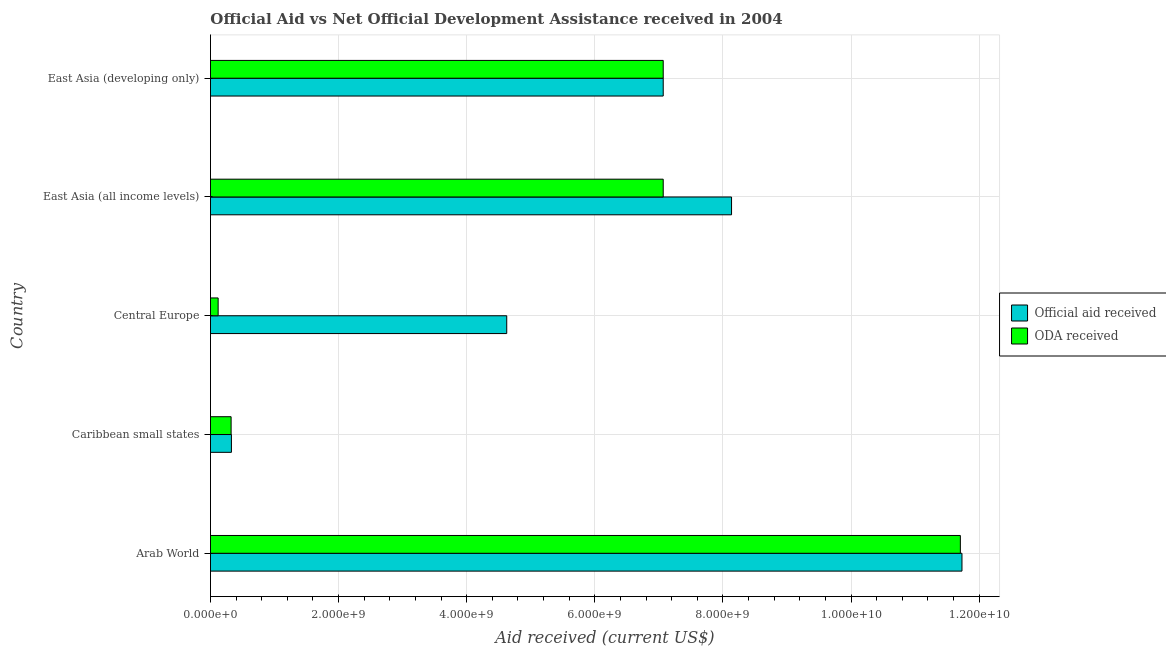How many different coloured bars are there?
Offer a very short reply. 2. Are the number of bars on each tick of the Y-axis equal?
Provide a short and direct response. Yes. How many bars are there on the 1st tick from the top?
Offer a very short reply. 2. What is the label of the 2nd group of bars from the top?
Your answer should be compact. East Asia (all income levels). In how many cases, is the number of bars for a given country not equal to the number of legend labels?
Provide a short and direct response. 0. What is the oda received in East Asia (all income levels)?
Make the answer very short. 7.07e+09. Across all countries, what is the maximum official aid received?
Provide a short and direct response. 1.17e+1. Across all countries, what is the minimum oda received?
Provide a succinct answer. 1.20e+08. In which country was the official aid received maximum?
Offer a very short reply. Arab World. In which country was the oda received minimum?
Offer a terse response. Central Europe. What is the total official aid received in the graph?
Your response must be concise. 3.19e+1. What is the difference between the official aid received in Caribbean small states and that in East Asia (developing only)?
Your answer should be compact. -6.74e+09. What is the difference between the official aid received in East Asia (all income levels) and the oda received in Arab World?
Provide a short and direct response. -3.57e+09. What is the average oda received per country?
Your answer should be very brief. 5.26e+09. What is the difference between the official aid received and oda received in Central Europe?
Give a very brief answer. 4.51e+09. In how many countries, is the official aid received greater than 10800000000 US$?
Give a very brief answer. 1. What is the ratio of the official aid received in Arab World to that in East Asia (all income levels)?
Give a very brief answer. 1.44. Is the official aid received in Arab World less than that in Central Europe?
Give a very brief answer. No. What is the difference between the highest and the second highest oda received?
Keep it short and to the point. 4.64e+09. What is the difference between the highest and the lowest oda received?
Make the answer very short. 1.16e+1. What does the 1st bar from the top in Arab World represents?
Offer a terse response. ODA received. What does the 2nd bar from the bottom in Central Europe represents?
Provide a short and direct response. ODA received. How many bars are there?
Keep it short and to the point. 10. What is the difference between two consecutive major ticks on the X-axis?
Your answer should be compact. 2.00e+09. Does the graph contain any zero values?
Provide a short and direct response. No. How are the legend labels stacked?
Your answer should be compact. Vertical. What is the title of the graph?
Offer a very short reply. Official Aid vs Net Official Development Assistance received in 2004 . Does "Enforce a contract" appear as one of the legend labels in the graph?
Your answer should be very brief. No. What is the label or title of the X-axis?
Provide a short and direct response. Aid received (current US$). What is the label or title of the Y-axis?
Offer a very short reply. Country. What is the Aid received (current US$) in Official aid received in Arab World?
Provide a succinct answer. 1.17e+1. What is the Aid received (current US$) of ODA received in Arab World?
Your answer should be compact. 1.17e+1. What is the Aid received (current US$) of Official aid received in Caribbean small states?
Offer a terse response. 3.27e+08. What is the Aid received (current US$) in ODA received in Caribbean small states?
Make the answer very short. 3.22e+08. What is the Aid received (current US$) in Official aid received in Central Europe?
Give a very brief answer. 4.63e+09. What is the Aid received (current US$) of ODA received in Central Europe?
Provide a short and direct response. 1.20e+08. What is the Aid received (current US$) of Official aid received in East Asia (all income levels)?
Give a very brief answer. 8.13e+09. What is the Aid received (current US$) in ODA received in East Asia (all income levels)?
Keep it short and to the point. 7.07e+09. What is the Aid received (current US$) in Official aid received in East Asia (developing only)?
Your response must be concise. 7.07e+09. What is the Aid received (current US$) in ODA received in East Asia (developing only)?
Provide a succinct answer. 7.07e+09. Across all countries, what is the maximum Aid received (current US$) of Official aid received?
Make the answer very short. 1.17e+1. Across all countries, what is the maximum Aid received (current US$) of ODA received?
Keep it short and to the point. 1.17e+1. Across all countries, what is the minimum Aid received (current US$) of Official aid received?
Your answer should be compact. 3.27e+08. Across all countries, what is the minimum Aid received (current US$) in ODA received?
Offer a terse response. 1.20e+08. What is the total Aid received (current US$) in Official aid received in the graph?
Ensure brevity in your answer.  3.19e+1. What is the total Aid received (current US$) in ODA received in the graph?
Your response must be concise. 2.63e+1. What is the difference between the Aid received (current US$) of Official aid received in Arab World and that in Caribbean small states?
Offer a very short reply. 1.14e+1. What is the difference between the Aid received (current US$) of ODA received in Arab World and that in Caribbean small states?
Make the answer very short. 1.14e+1. What is the difference between the Aid received (current US$) in Official aid received in Arab World and that in Central Europe?
Your response must be concise. 7.11e+09. What is the difference between the Aid received (current US$) in ODA received in Arab World and that in Central Europe?
Your answer should be very brief. 1.16e+1. What is the difference between the Aid received (current US$) in Official aid received in Arab World and that in East Asia (all income levels)?
Offer a terse response. 3.60e+09. What is the difference between the Aid received (current US$) in ODA received in Arab World and that in East Asia (all income levels)?
Give a very brief answer. 4.64e+09. What is the difference between the Aid received (current US$) in Official aid received in Arab World and that in East Asia (developing only)?
Your answer should be compact. 4.66e+09. What is the difference between the Aid received (current US$) of ODA received in Arab World and that in East Asia (developing only)?
Give a very brief answer. 4.64e+09. What is the difference between the Aid received (current US$) in Official aid received in Caribbean small states and that in Central Europe?
Ensure brevity in your answer.  -4.30e+09. What is the difference between the Aid received (current US$) of ODA received in Caribbean small states and that in Central Europe?
Ensure brevity in your answer.  2.03e+08. What is the difference between the Aid received (current US$) of Official aid received in Caribbean small states and that in East Asia (all income levels)?
Offer a very short reply. -7.81e+09. What is the difference between the Aid received (current US$) in ODA received in Caribbean small states and that in East Asia (all income levels)?
Offer a very short reply. -6.75e+09. What is the difference between the Aid received (current US$) of Official aid received in Caribbean small states and that in East Asia (developing only)?
Offer a very short reply. -6.74e+09. What is the difference between the Aid received (current US$) of ODA received in Caribbean small states and that in East Asia (developing only)?
Offer a very short reply. -6.75e+09. What is the difference between the Aid received (current US$) in Official aid received in Central Europe and that in East Asia (all income levels)?
Your answer should be compact. -3.51e+09. What is the difference between the Aid received (current US$) in ODA received in Central Europe and that in East Asia (all income levels)?
Offer a very short reply. -6.95e+09. What is the difference between the Aid received (current US$) in Official aid received in Central Europe and that in East Asia (developing only)?
Offer a very short reply. -2.44e+09. What is the difference between the Aid received (current US$) of ODA received in Central Europe and that in East Asia (developing only)?
Your response must be concise. -6.95e+09. What is the difference between the Aid received (current US$) of Official aid received in East Asia (all income levels) and that in East Asia (developing only)?
Your answer should be very brief. 1.07e+09. What is the difference between the Aid received (current US$) in ODA received in East Asia (all income levels) and that in East Asia (developing only)?
Your response must be concise. 0. What is the difference between the Aid received (current US$) of Official aid received in Arab World and the Aid received (current US$) of ODA received in Caribbean small states?
Provide a succinct answer. 1.14e+1. What is the difference between the Aid received (current US$) of Official aid received in Arab World and the Aid received (current US$) of ODA received in Central Europe?
Your response must be concise. 1.16e+1. What is the difference between the Aid received (current US$) in Official aid received in Arab World and the Aid received (current US$) in ODA received in East Asia (all income levels)?
Your answer should be compact. 4.66e+09. What is the difference between the Aid received (current US$) in Official aid received in Arab World and the Aid received (current US$) in ODA received in East Asia (developing only)?
Offer a very short reply. 4.66e+09. What is the difference between the Aid received (current US$) of Official aid received in Caribbean small states and the Aid received (current US$) of ODA received in Central Europe?
Your response must be concise. 2.07e+08. What is the difference between the Aid received (current US$) in Official aid received in Caribbean small states and the Aid received (current US$) in ODA received in East Asia (all income levels)?
Provide a short and direct response. -6.74e+09. What is the difference between the Aid received (current US$) in Official aid received in Caribbean small states and the Aid received (current US$) in ODA received in East Asia (developing only)?
Your answer should be compact. -6.74e+09. What is the difference between the Aid received (current US$) in Official aid received in Central Europe and the Aid received (current US$) in ODA received in East Asia (all income levels)?
Keep it short and to the point. -2.44e+09. What is the difference between the Aid received (current US$) in Official aid received in Central Europe and the Aid received (current US$) in ODA received in East Asia (developing only)?
Offer a terse response. -2.44e+09. What is the difference between the Aid received (current US$) in Official aid received in East Asia (all income levels) and the Aid received (current US$) in ODA received in East Asia (developing only)?
Offer a very short reply. 1.07e+09. What is the average Aid received (current US$) of Official aid received per country?
Your response must be concise. 6.38e+09. What is the average Aid received (current US$) of ODA received per country?
Provide a succinct answer. 5.26e+09. What is the difference between the Aid received (current US$) of Official aid received and Aid received (current US$) of ODA received in Arab World?
Offer a terse response. 2.51e+07. What is the difference between the Aid received (current US$) of Official aid received and Aid received (current US$) of ODA received in Caribbean small states?
Give a very brief answer. 4.75e+06. What is the difference between the Aid received (current US$) of Official aid received and Aid received (current US$) of ODA received in Central Europe?
Your answer should be compact. 4.51e+09. What is the difference between the Aid received (current US$) in Official aid received and Aid received (current US$) in ODA received in East Asia (all income levels)?
Give a very brief answer. 1.07e+09. What is the difference between the Aid received (current US$) in Official aid received and Aid received (current US$) in ODA received in East Asia (developing only)?
Your answer should be compact. 0. What is the ratio of the Aid received (current US$) of Official aid received in Arab World to that in Caribbean small states?
Provide a succinct answer. 35.87. What is the ratio of the Aid received (current US$) of ODA received in Arab World to that in Caribbean small states?
Give a very brief answer. 36.33. What is the ratio of the Aid received (current US$) of Official aid received in Arab World to that in Central Europe?
Your answer should be compact. 2.54. What is the ratio of the Aid received (current US$) of ODA received in Arab World to that in Central Europe?
Your response must be concise. 97.84. What is the ratio of the Aid received (current US$) of Official aid received in Arab World to that in East Asia (all income levels)?
Keep it short and to the point. 1.44. What is the ratio of the Aid received (current US$) in ODA received in Arab World to that in East Asia (all income levels)?
Provide a short and direct response. 1.66. What is the ratio of the Aid received (current US$) of Official aid received in Arab World to that in East Asia (developing only)?
Offer a terse response. 1.66. What is the ratio of the Aid received (current US$) in ODA received in Arab World to that in East Asia (developing only)?
Offer a very short reply. 1.66. What is the ratio of the Aid received (current US$) in Official aid received in Caribbean small states to that in Central Europe?
Ensure brevity in your answer.  0.07. What is the ratio of the Aid received (current US$) of ODA received in Caribbean small states to that in Central Europe?
Your answer should be compact. 2.69. What is the ratio of the Aid received (current US$) of Official aid received in Caribbean small states to that in East Asia (all income levels)?
Offer a terse response. 0.04. What is the ratio of the Aid received (current US$) of ODA received in Caribbean small states to that in East Asia (all income levels)?
Make the answer very short. 0.05. What is the ratio of the Aid received (current US$) in Official aid received in Caribbean small states to that in East Asia (developing only)?
Provide a succinct answer. 0.05. What is the ratio of the Aid received (current US$) in ODA received in Caribbean small states to that in East Asia (developing only)?
Offer a very short reply. 0.05. What is the ratio of the Aid received (current US$) in Official aid received in Central Europe to that in East Asia (all income levels)?
Your answer should be very brief. 0.57. What is the ratio of the Aid received (current US$) of ODA received in Central Europe to that in East Asia (all income levels)?
Give a very brief answer. 0.02. What is the ratio of the Aid received (current US$) in Official aid received in Central Europe to that in East Asia (developing only)?
Offer a very short reply. 0.65. What is the ratio of the Aid received (current US$) of ODA received in Central Europe to that in East Asia (developing only)?
Provide a short and direct response. 0.02. What is the ratio of the Aid received (current US$) in Official aid received in East Asia (all income levels) to that in East Asia (developing only)?
Give a very brief answer. 1.15. What is the difference between the highest and the second highest Aid received (current US$) of Official aid received?
Your answer should be very brief. 3.60e+09. What is the difference between the highest and the second highest Aid received (current US$) in ODA received?
Ensure brevity in your answer.  4.64e+09. What is the difference between the highest and the lowest Aid received (current US$) of Official aid received?
Offer a very short reply. 1.14e+1. What is the difference between the highest and the lowest Aid received (current US$) in ODA received?
Keep it short and to the point. 1.16e+1. 